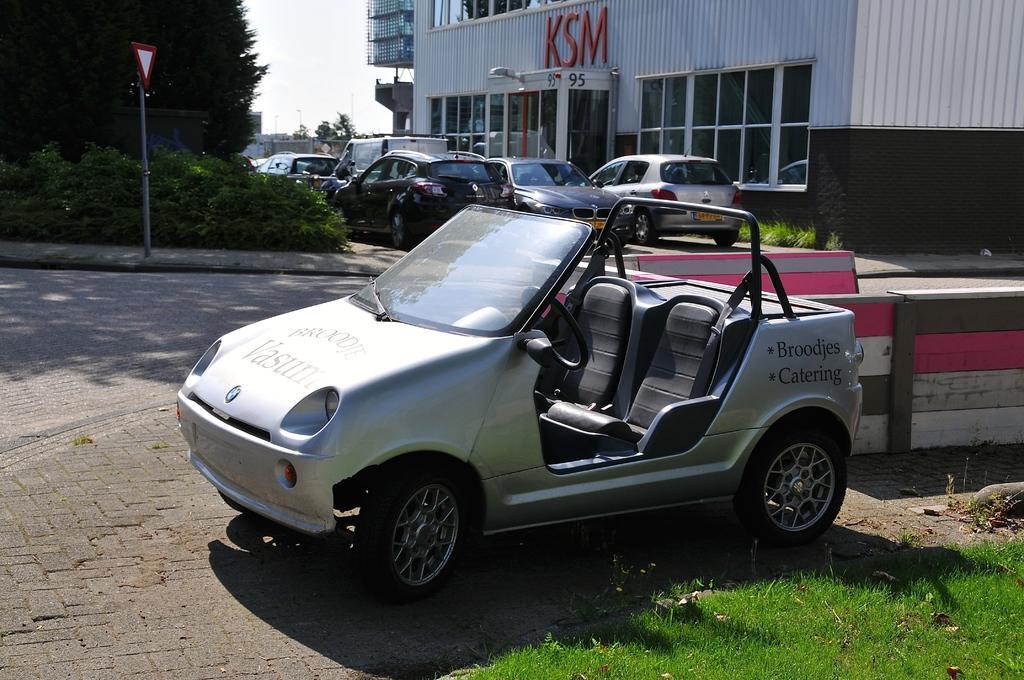Could you give a brief overview of what you see in this image? In this image, we can see so many vehicles. Here there is a road, pole, sign board, plants, trees. Top of the image, we can see a house with walls and glass windows. At the bottom, there is a grass. 